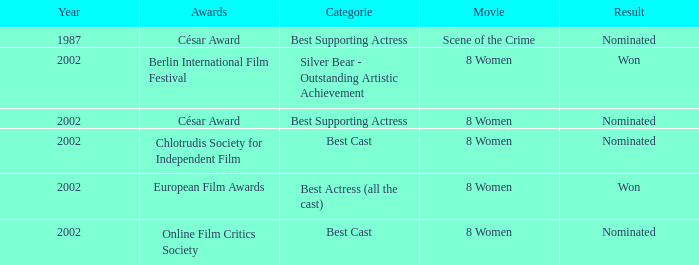What was the segment in 2002 at the berlin international film festival in which danielle darrieux took part? Silver Bear - Outstanding Artistic Achievement. 